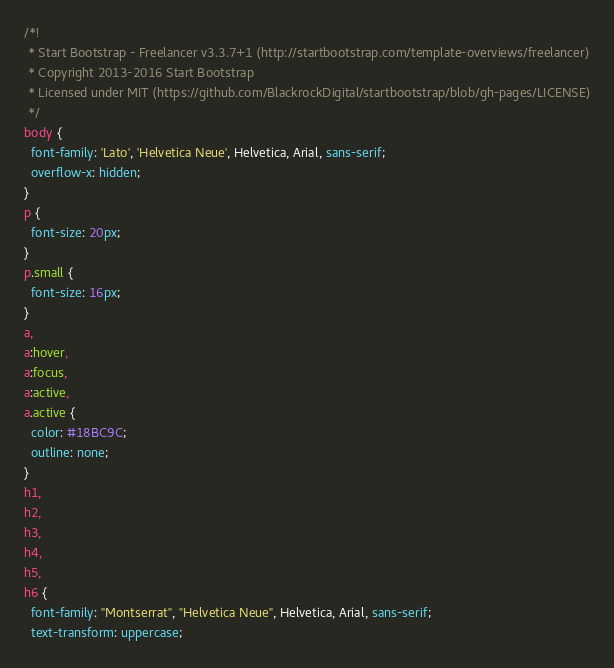<code> <loc_0><loc_0><loc_500><loc_500><_CSS_>/*!
 * Start Bootstrap - Freelancer v3.3.7+1 (http://startbootstrap.com/template-overviews/freelancer)
 * Copyright 2013-2016 Start Bootstrap
 * Licensed under MIT (https://github.com/BlackrockDigital/startbootstrap/blob/gh-pages/LICENSE)
 */
body {
  font-family: 'Lato', 'Helvetica Neue', Helvetica, Arial, sans-serif;
  overflow-x: hidden;
}
p {
  font-size: 20px;
}
p.small {
  font-size: 16px;
}
a,
a:hover,
a:focus,
a:active,
a.active {
  color: #18BC9C;
  outline: none;
}
h1,
h2,
h3,
h4,
h5,
h6 {
  font-family: "Montserrat", "Helvetica Neue", Helvetica, Arial, sans-serif;
  text-transform: uppercase;</code> 